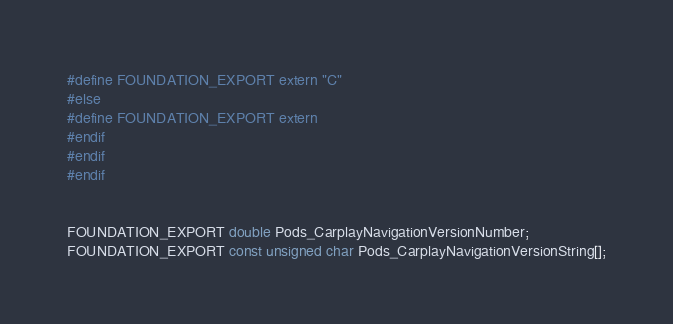<code> <loc_0><loc_0><loc_500><loc_500><_C_>#define FOUNDATION_EXPORT extern "C"
#else
#define FOUNDATION_EXPORT extern
#endif
#endif
#endif


FOUNDATION_EXPORT double Pods_CarplayNavigationVersionNumber;
FOUNDATION_EXPORT const unsigned char Pods_CarplayNavigationVersionString[];

</code> 